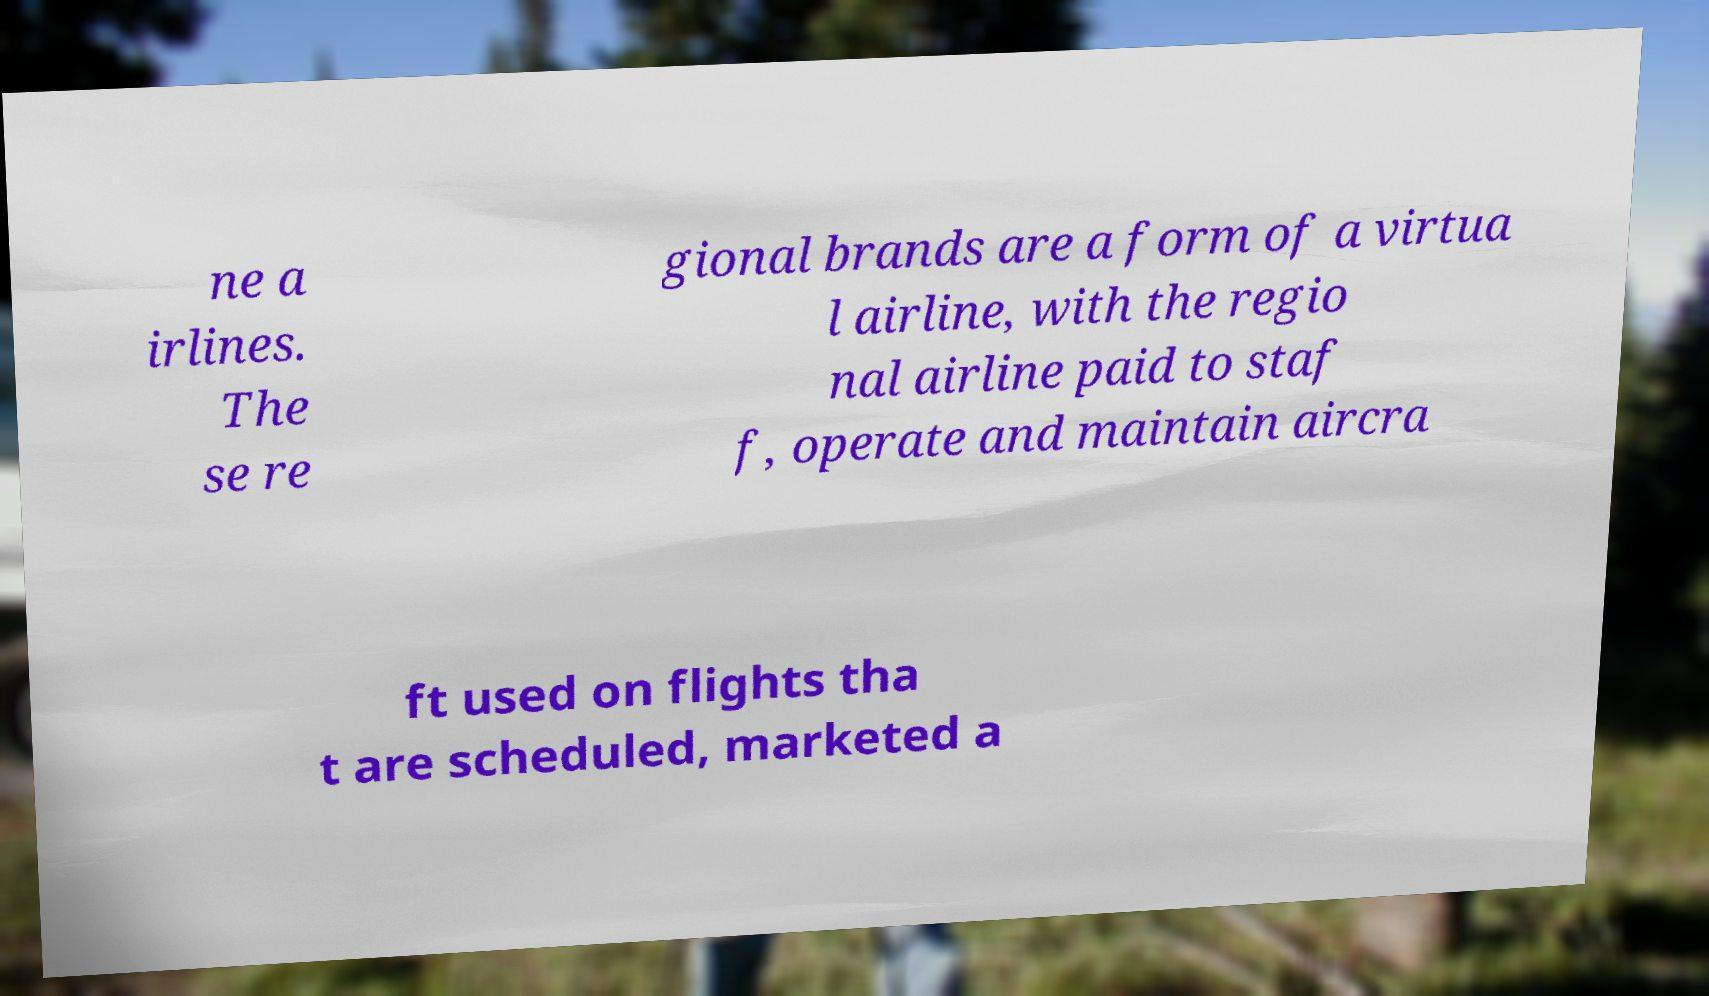Please identify and transcribe the text found in this image. ne a irlines. The se re gional brands are a form of a virtua l airline, with the regio nal airline paid to staf f, operate and maintain aircra ft used on flights tha t are scheduled, marketed a 